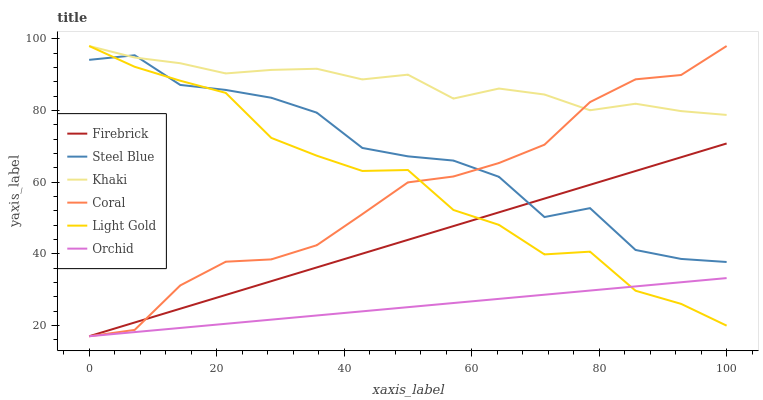Does Orchid have the minimum area under the curve?
Answer yes or no. Yes. Does Khaki have the maximum area under the curve?
Answer yes or no. Yes. Does Coral have the minimum area under the curve?
Answer yes or no. No. Does Coral have the maximum area under the curve?
Answer yes or no. No. Is Orchid the smoothest?
Answer yes or no. Yes. Is Steel Blue the roughest?
Answer yes or no. Yes. Is Coral the smoothest?
Answer yes or no. No. Is Coral the roughest?
Answer yes or no. No. Does Coral have the lowest value?
Answer yes or no. Yes. Does Steel Blue have the lowest value?
Answer yes or no. No. Does Light Gold have the highest value?
Answer yes or no. Yes. Does Steel Blue have the highest value?
Answer yes or no. No. Is Orchid less than Khaki?
Answer yes or no. Yes. Is Khaki greater than Orchid?
Answer yes or no. Yes. Does Light Gold intersect Firebrick?
Answer yes or no. Yes. Is Light Gold less than Firebrick?
Answer yes or no. No. Is Light Gold greater than Firebrick?
Answer yes or no. No. Does Orchid intersect Khaki?
Answer yes or no. No. 